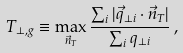<formula> <loc_0><loc_0><loc_500><loc_500>T _ { \perp , g } \equiv \max _ { \vec { n } _ { T } } \frac { \sum _ { i } | { \vec { q } } _ { \perp i } \cdot { \vec { n } _ { T } } | } { \sum _ { i } q _ { \perp i } } \, ,</formula> 